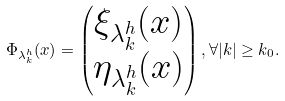<formula> <loc_0><loc_0><loc_500><loc_500>\Phi _ { \lambda ^ { h } _ { k } } ( x ) = \begin{pmatrix} \xi _ { \lambda ^ { h } _ { k } } ( x ) \\ \eta _ { \lambda ^ { h } _ { k } } ( x ) \end{pmatrix} , \forall | k | \geq k _ { 0 } .</formula> 